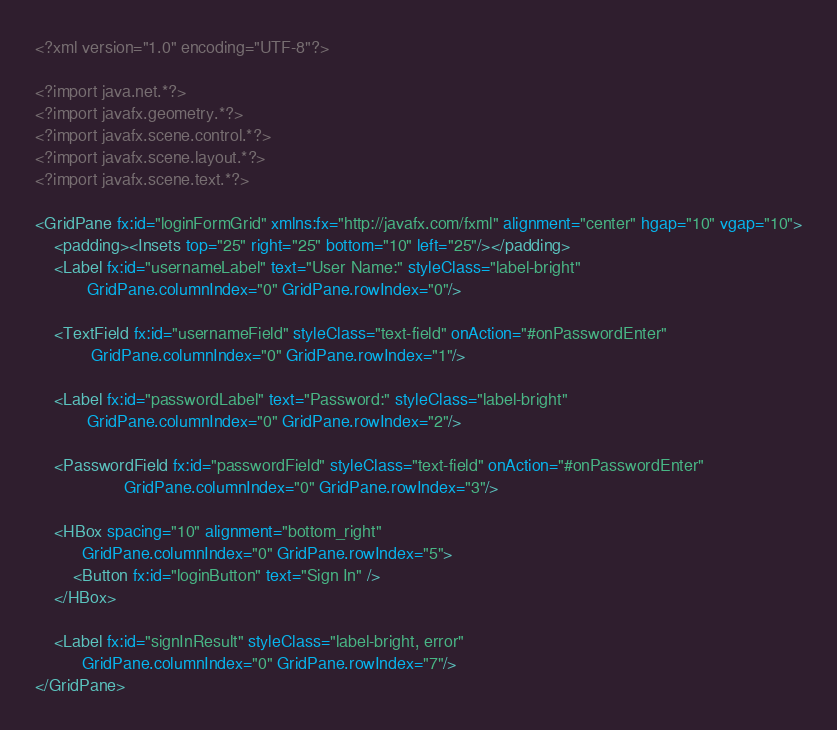Convert code to text. <code><loc_0><loc_0><loc_500><loc_500><_XML_><?xml version="1.0" encoding="UTF-8"?>

<?import java.net.*?>
<?import javafx.geometry.*?>
<?import javafx.scene.control.*?>
<?import javafx.scene.layout.*?>
<?import javafx.scene.text.*?>

<GridPane fx:id="loginFormGrid" xmlns:fx="http://javafx.com/fxml" alignment="center" hgap="10" vgap="10">
	<padding><Insets top="25" right="25" bottom="10" left="25"/></padding>
	<Label fx:id="usernameLabel" text="User Name:" styleClass="label-bright"
		   GridPane.columnIndex="0" GridPane.rowIndex="0"/>

	<TextField fx:id="usernameField" styleClass="text-field" onAction="#onPasswordEnter"
			GridPane.columnIndex="0" GridPane.rowIndex="1"/>

	<Label fx:id="passwordLabel" text="Password:" styleClass="label-bright"
		   GridPane.columnIndex="0" GridPane.rowIndex="2"/>

	<PasswordField fx:id="passwordField" styleClass="text-field" onAction="#onPasswordEnter"
				   GridPane.columnIndex="0" GridPane.rowIndex="3"/>

	<HBox spacing="10" alignment="bottom_right"
		  GridPane.columnIndex="0" GridPane.rowIndex="5">
		<Button fx:id="loginButton" text="Sign In" />
	</HBox>

	<Label fx:id="signInResult" styleClass="label-bright, error"
		  GridPane.columnIndex="0" GridPane.rowIndex="7"/>
</GridPane>
</code> 